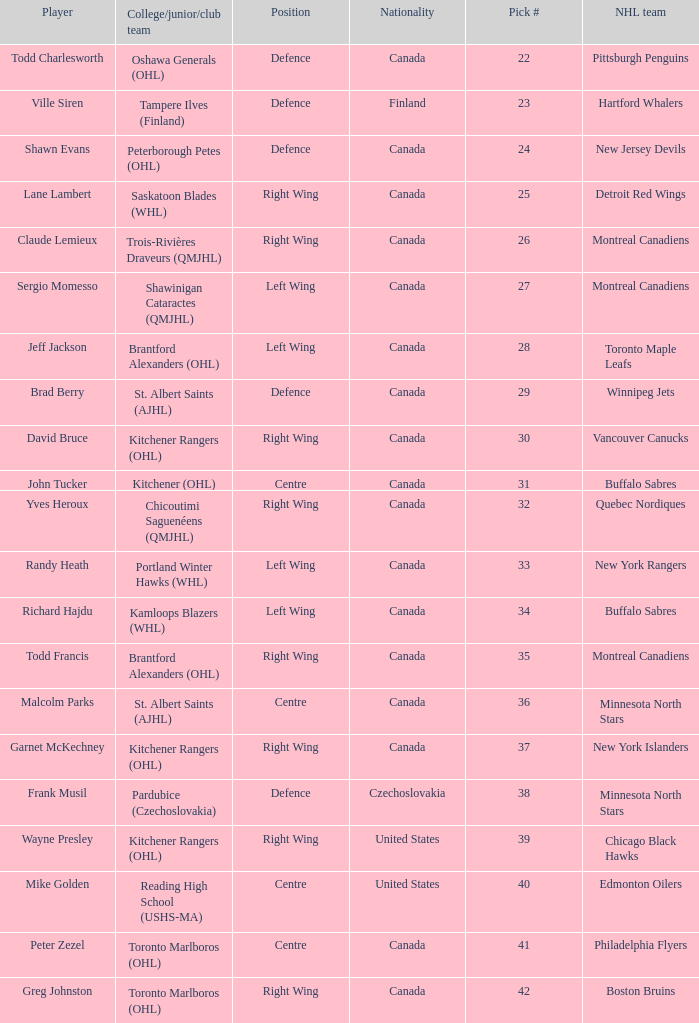How many times is the nhl team the winnipeg jets? 1.0. 